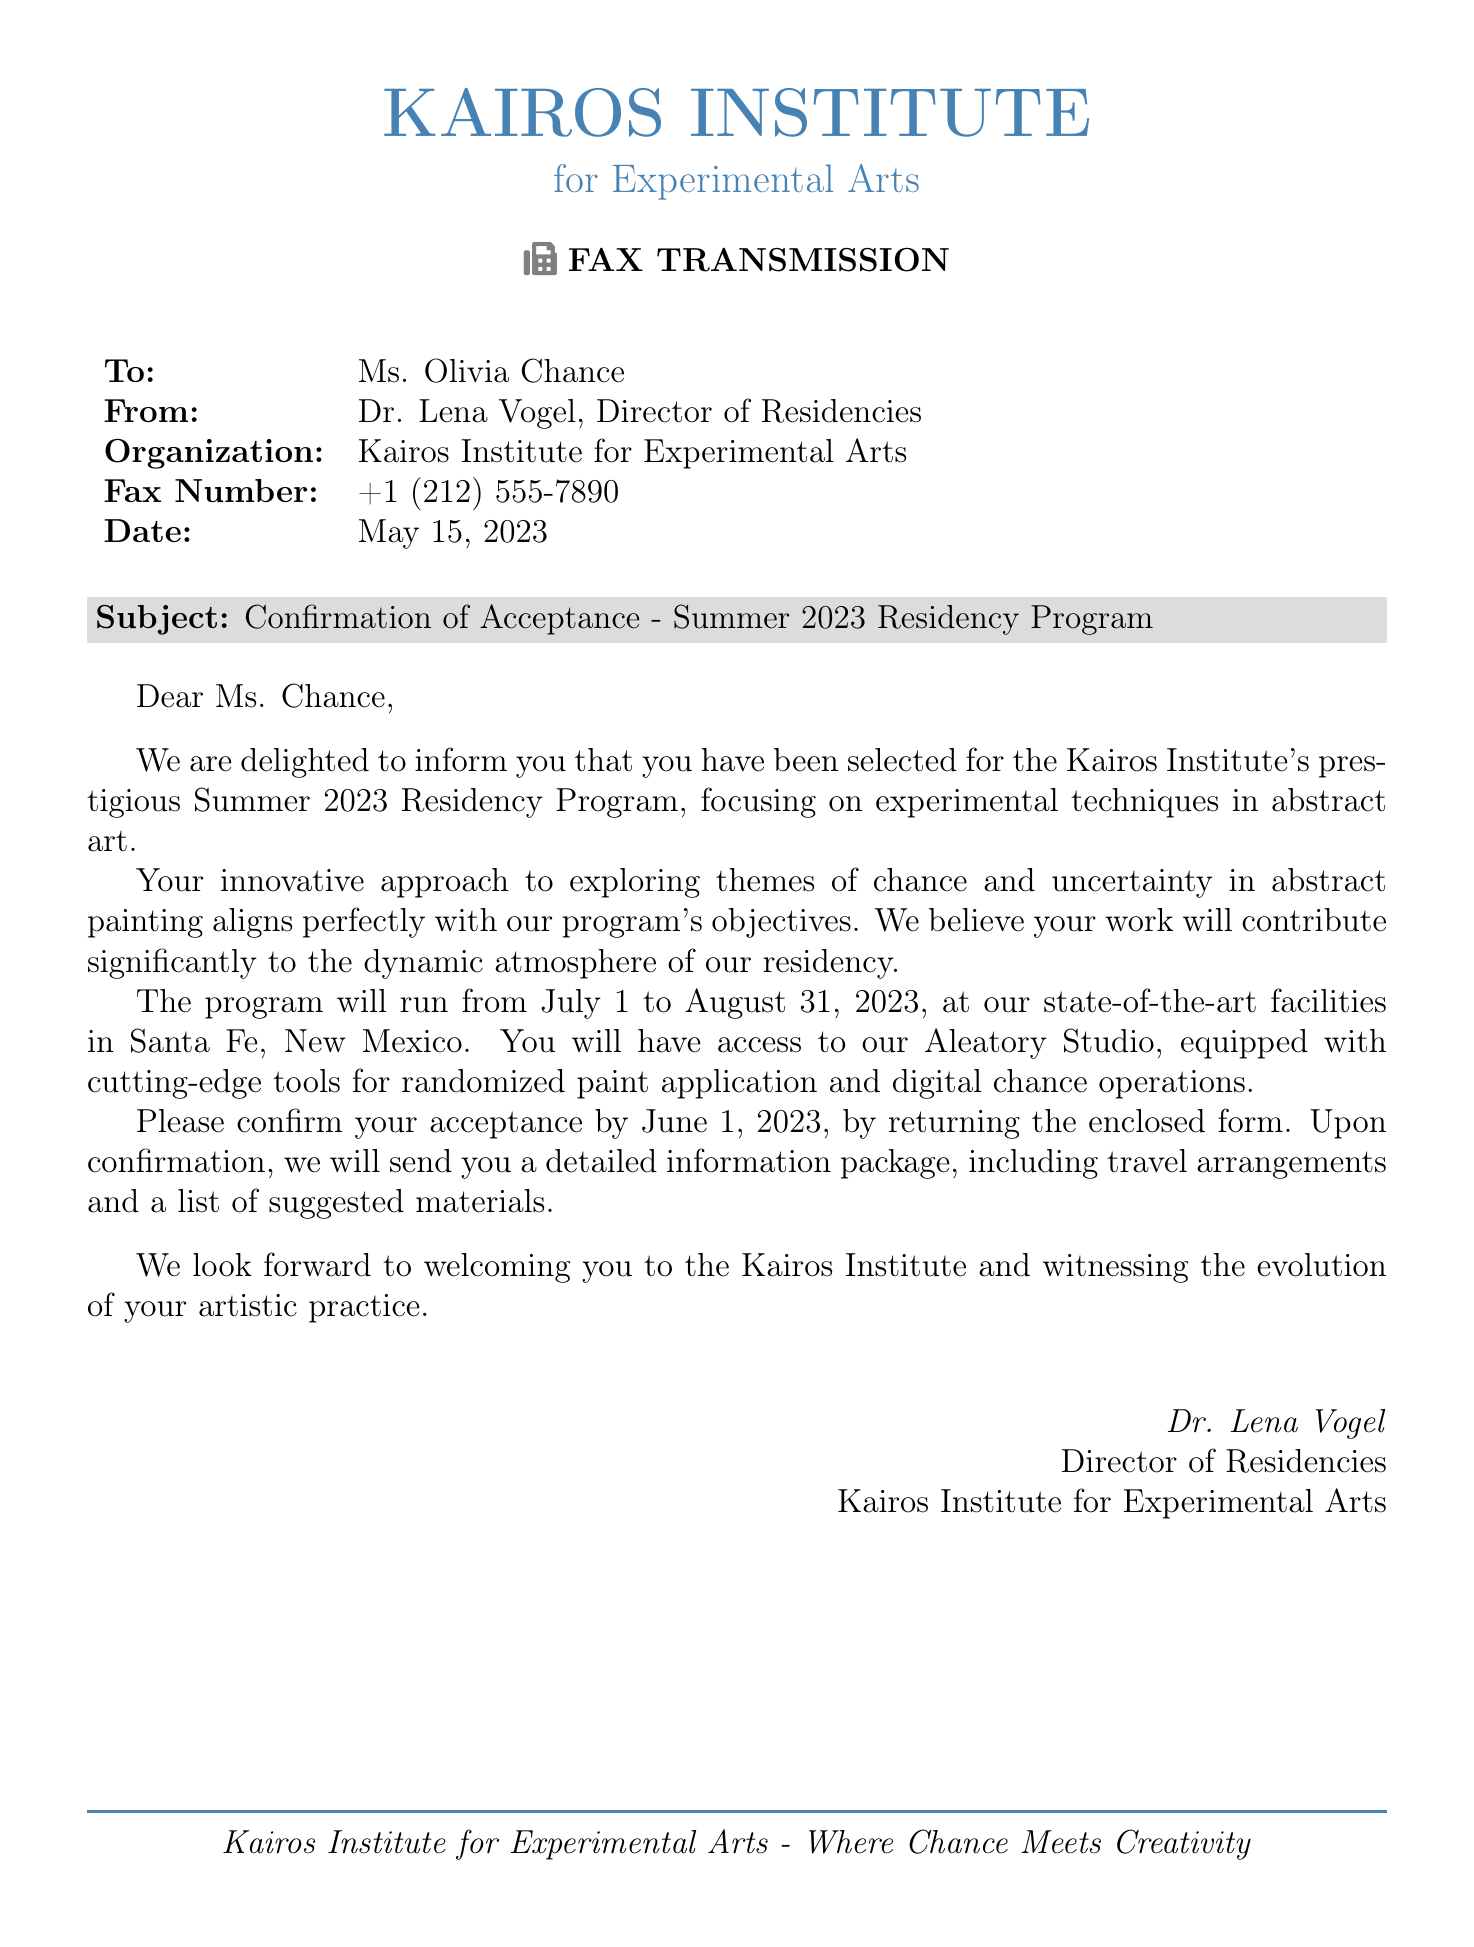What is the name of the institute? The name of the institute is mentioned in the document's header.
Answer: Kairos Institute Who is the recipient of the fax? The recipient's name is listed directly after the "To:" line.
Answer: Ms. Olivia Chance What is the focus of the residency program? The primary focus is stated in the subject line of the document.
Answer: Experimental techniques in abstract art What are the dates of the residency program? The specific dates of the program are found in the body of the document.
Answer: July 1 to August 31, 2023 Who signed the fax? The signatory's name is located near the end of the document.
Answer: Dr. Lena Vogel What is the deadline for confirming acceptance? The deadline for confirmation is clearly specified in the body of the fax.
Answer: June 1, 2023 What facility will be used during the residency? The document mentions a specific studio available during the residency.
Answer: Aleatory Studio Where is the residency program located? The specific location is indicated in the body of the document.
Answer: Santa Fe, New Mexico What will be sent after confirmation? The document states what information will be sent upon confirmation.
Answer: Detailed information package 